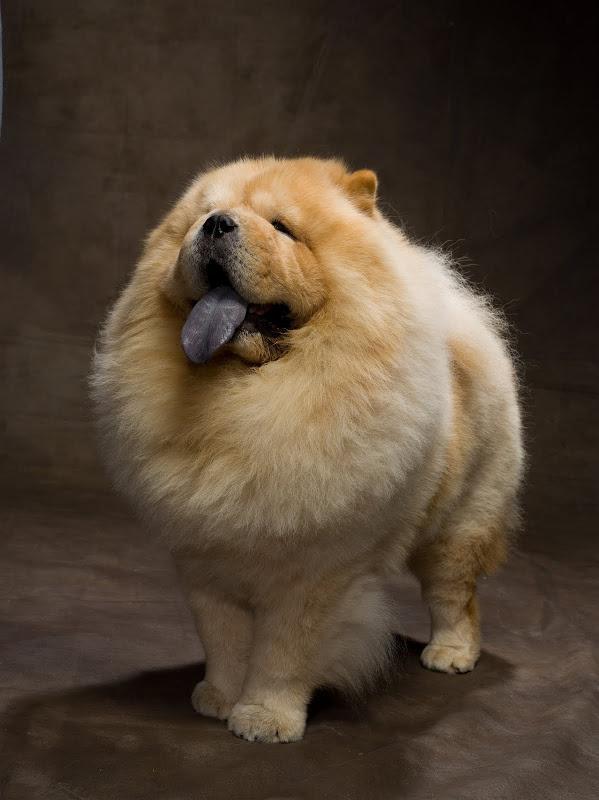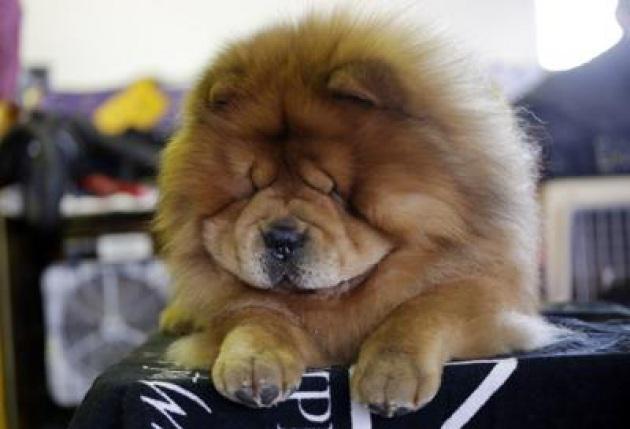The first image is the image on the left, the second image is the image on the right. For the images shown, is this caption "The dog in the image on the right is standing on all fours." true? Answer yes or no. No. 